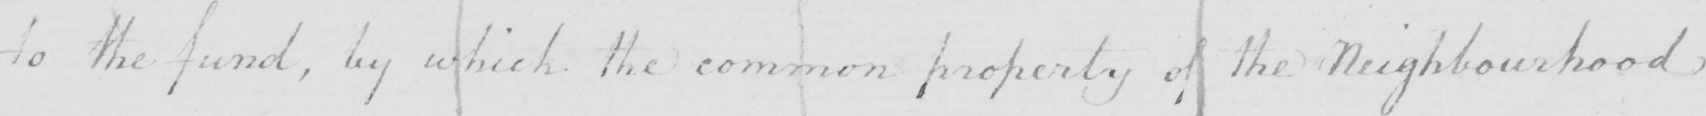Please transcribe the handwritten text in this image. to the fund , by which the common property of the Neighbourhood 